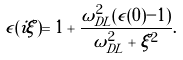<formula> <loc_0><loc_0><loc_500><loc_500>\epsilon ( i \xi ) = 1 + \frac { \omega _ { D L } ^ { 2 } ( \epsilon ( 0 ) - 1 ) } { \omega _ { D L } ^ { 2 } + \xi ^ { 2 } } .</formula> 